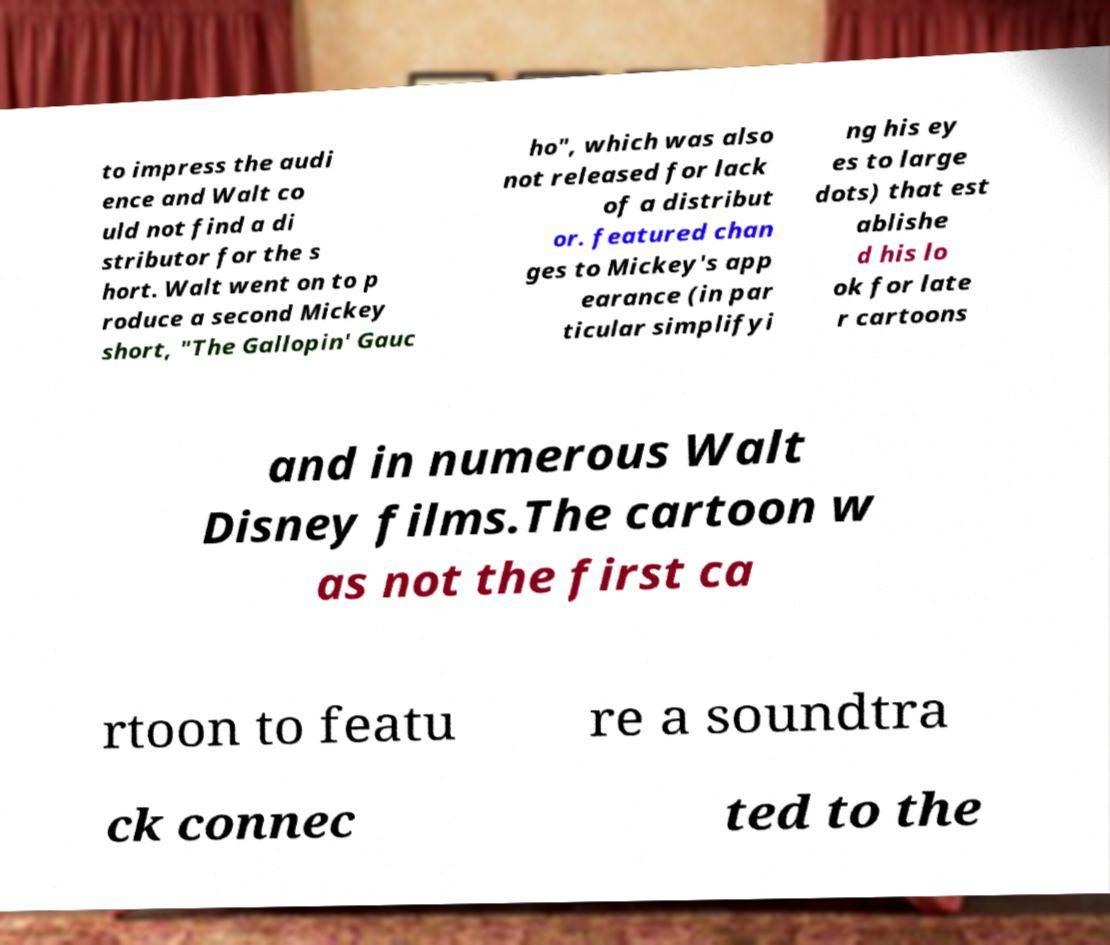What messages or text are displayed in this image? I need them in a readable, typed format. to impress the audi ence and Walt co uld not find a di stributor for the s hort. Walt went on to p roduce a second Mickey short, "The Gallopin' Gauc ho", which was also not released for lack of a distribut or. featured chan ges to Mickey's app earance (in par ticular simplifyi ng his ey es to large dots) that est ablishe d his lo ok for late r cartoons and in numerous Walt Disney films.The cartoon w as not the first ca rtoon to featu re a soundtra ck connec ted to the 